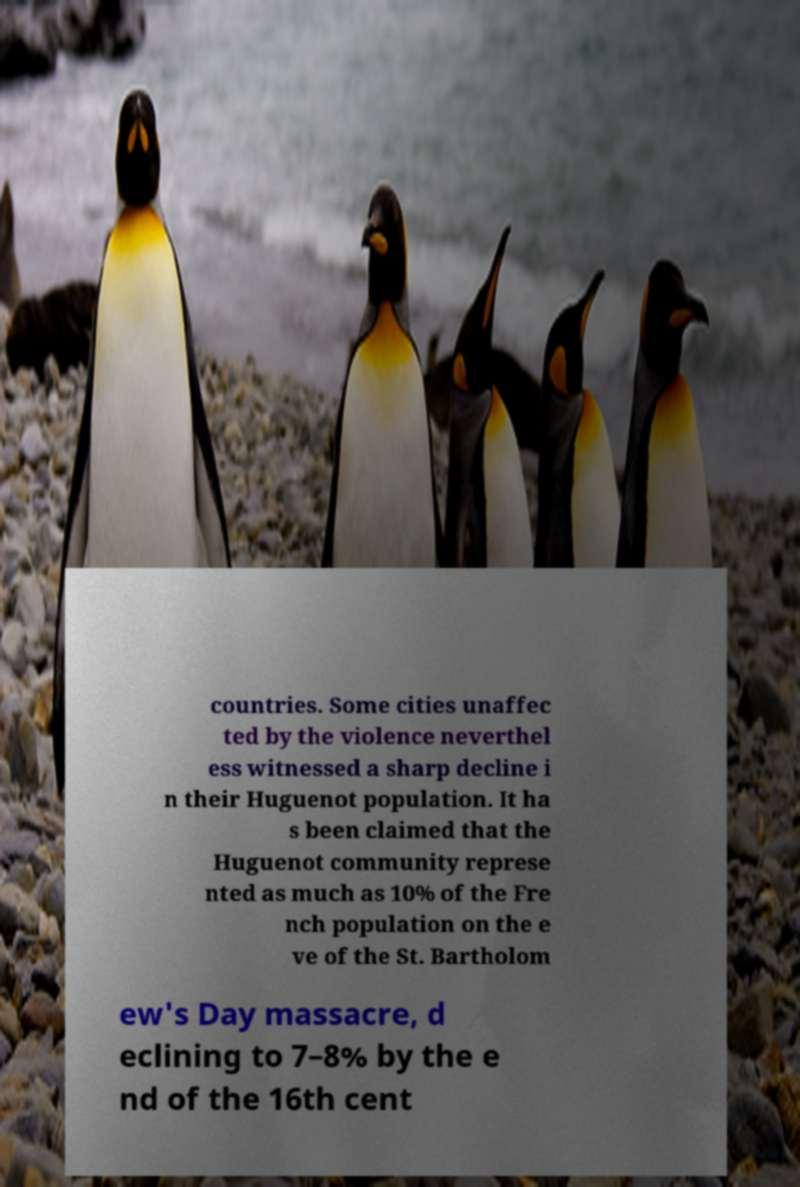Could you extract and type out the text from this image? countries. Some cities unaffec ted by the violence neverthel ess witnessed a sharp decline i n their Huguenot population. It ha s been claimed that the Huguenot community represe nted as much as 10% of the Fre nch population on the e ve of the St. Bartholom ew's Day massacre, d eclining to 7–8% by the e nd of the 16th cent 